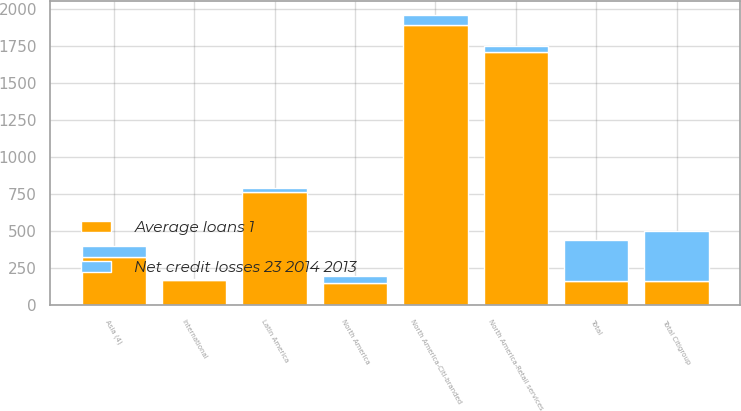Convert chart. <chart><loc_0><loc_0><loc_500><loc_500><stacked_bar_chart><ecel><fcel>Total<fcel>North America<fcel>Latin America<fcel>Asia (4)<fcel>North America-Citi-branded<fcel>North America-Retail services<fcel>International<fcel>Total Citigroup<nl><fcel>Net credit losses 23 2014 2013<fcel>281.3<fcel>49.5<fcel>25<fcel>73.6<fcel>64<fcel>43.4<fcel>5<fcel>342.9<nl><fcel>Average loans 1<fcel>162.5<fcel>152<fcel>764<fcel>325<fcel>1892<fcel>1709<fcel>173<fcel>162.5<nl></chart> 